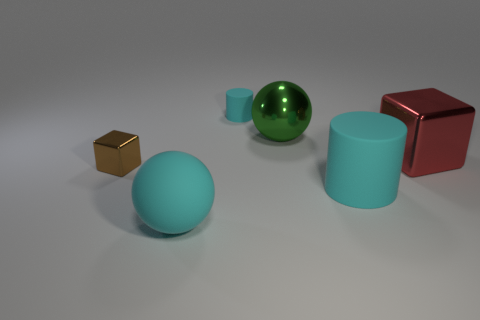Subtract all blue balls. Subtract all red cubes. How many balls are left? 2 Add 2 small blue rubber blocks. How many objects exist? 8 Subtract all balls. How many objects are left? 4 Subtract 0 blue cylinders. How many objects are left? 6 Subtract all brown metallic blocks. Subtract all small cyan cylinders. How many objects are left? 4 Add 4 brown metallic cubes. How many brown metallic cubes are left? 5 Add 3 tiny cyan things. How many tiny cyan things exist? 4 